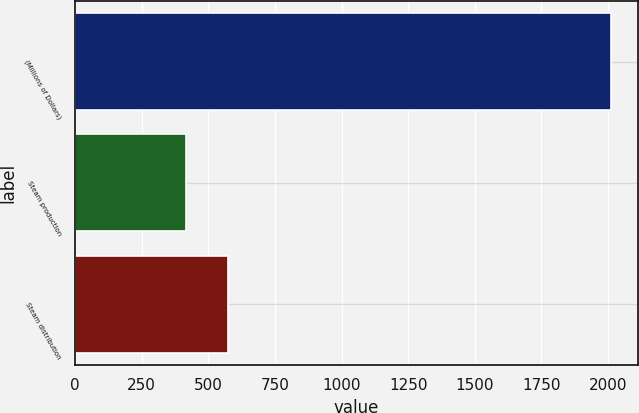<chart> <loc_0><loc_0><loc_500><loc_500><bar_chart><fcel>(Millions of Dollars)<fcel>Steam production<fcel>Steam distribution<nl><fcel>2011<fcel>415<fcel>574.6<nl></chart> 